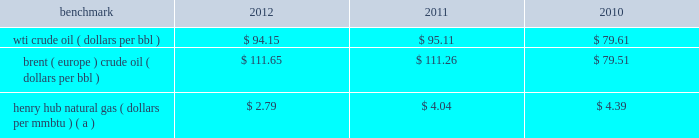Item 7 .
Management 2019s discussion and analysis of financial condition and results of operations we are an international energy company with operations in the u.s. , canada , africa , the middle east and europe .
Our operations are organized into three reportable segments : 2022 e&p which explores for , produces and markets liquid hydrocarbons and natural gas on a worldwide basis .
2022 osm which mines , extracts and transports bitumen from oil sands deposits in alberta , canada , and upgrades the bitumen to produce and market synthetic crude oil and vacuum gas oil .
2022 ig which produces and markets products manufactured from natural gas , such as lng and methanol , in e.g .
Certain sections of management 2019s discussion and analysis of financial condition and results of operations include forward- looking statements concerning trends or events potentially affecting our business .
These statements typically contain words such as "anticipates" "believes" "estimates" "expects" "targets" "plans" "projects" "could" "may" "should" "would" or similar words indicating that future outcomes are uncertain .
In accordance with "safe harbor" provisions of the private securities litigation reform act of 1995 , these statements are accompanied by cautionary language identifying important factors , though not necessarily all such factors , which could cause future outcomes to differ materially from those set forth in forward-looking statements .
For additional risk factors affecting our business , see item 1a .
Risk factors in this annual report on form 10-k .
Management 2019s discussion and analysis of financial condition and results of operations should be read in conjunction with the information under item 1 .
Business , item 1a .
Risk factors and item 8 .
Financial statements and supplementary data found in this annual report on form 10-k .
Spin-off downstream business on june 30 , 2011 , the spin-off of marathon 2019s downstream business was completed , creating two independent energy companies : marathon oil and mpc .
Marathon stockholders at the close of business on the record date of june 27 , 2011 received one share of mpc common stock for every two shares of marathon common stock held .
A private letter tax ruling received in june 2011 from the irs affirmed the tax-free nature of the spin-off .
Activities related to the downstream business have been treated as discontinued operations in 2011 and 2010 ( see item 8 .
Financial statements and supplementary data 2013 note 3 to the consolidated financial statements for additional information ) .
Overview 2013 market conditions exploration and production prevailing prices for the various grades of crude oil and natural gas that we produce significantly impact our revenues and cash flows .
The table lists benchmark crude oil and natural gas price annual averages for the past three years. .
Henry hub natural gas ( dollars per mmbtu ) ( a ) $ 2.79 $ 4.04 $ 4.39 ( a ) settlement date average .
Liquid hydrocarbon 2013 prices of crude oil have been volatile in recent years , but less so when comparing annual averages for 2012 and 2011 .
In 2011 , crude prices increased over 2010 levels , with increases in brent averages outstripping those in wti .
The quality , location and composition of our liquid hydrocarbon production mix will cause our u.s .
Liquid hydrocarbon realizations to differ from the wti benchmark .
In 2012 , 2011 and 2010 , the percentage of our u.s .
Crude oil and condensate production that was sour averaged 37 percent , 58 percent and 68 percent .
Sour crude contains more sulfur and tends to be heavier than light sweet crude oil so that refining it is more costly and produces lower value products ; therefore , sour crude is considered of lower quality and typically sells at a discount to wti .
The percentage of our u.s .
Crude and condensate production that is sour has been decreasing as onshore production from the eagle ford and bakken shale plays increases and production from the gulf of mexico declines .
In recent years , crude oil sold along the u.s .
Gulf coast has been priced at a premium to wti because the louisiana light sweet benchmark has been tracking brent , while production from inland areas farther from large refineries has been at a discount to wti .
Ngls were 10 percent , 7 percent and 6 percent of our u.s .
Liquid hydrocarbon sales in 2012 , 2011 and 2010 .
In 2012 , our sales of ngls increased due to our development of u.s .
Unconventional liquids-rich plays. .
Between 2012 and 2011 , what was the change in the percentage of crude oil and condensate production that was sour? 
Computations: (37 - 58)
Answer: -21.0. 